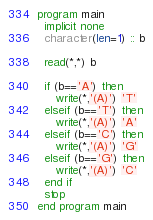Convert code to text. <code><loc_0><loc_0><loc_500><loc_500><_FORTRAN_>program main
  implicit none
  character(len=1) :: b

  read(*,*) b

  if (b=='A') then
     write(*,'(A)') 'T'
  elseif (b=='T') then
     write(*,'(A)') 'A'
  elseif (b=='C') then
     write(*,'(A)') 'G'
  elseif (b=='G') then
     write(*,'(A)') 'C'
  end if
  stop
end program main
</code> 